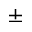Convert formula to latex. <formula><loc_0><loc_0><loc_500><loc_500>\pm</formula> 